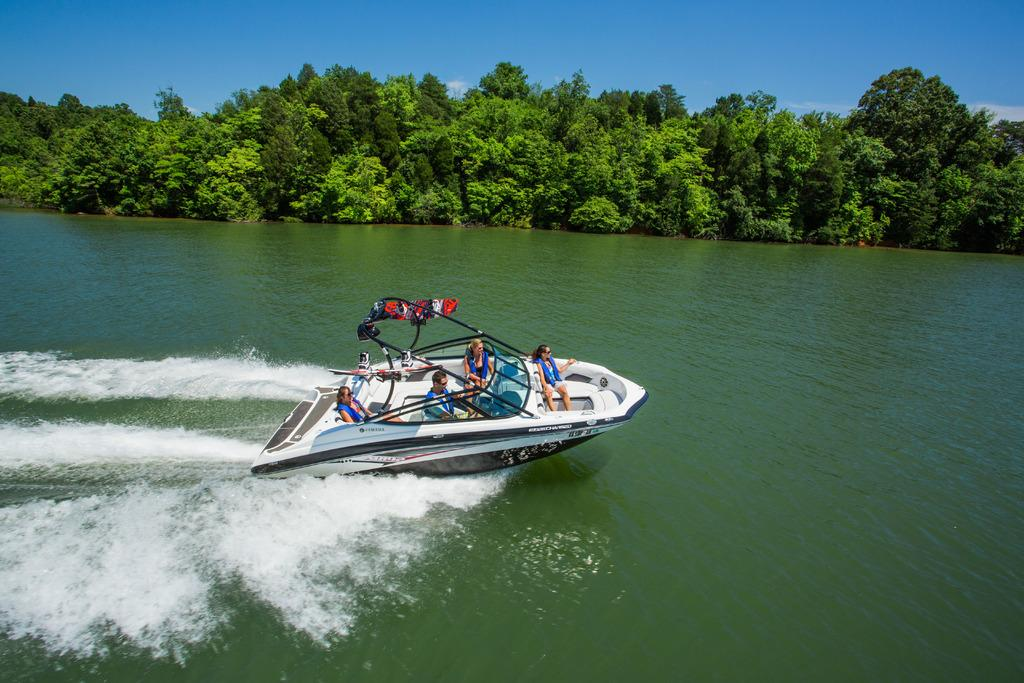What is the main subject in the center of the image? There is a steamer boat in the center of the image. Where is the boat located? The boat is on the water. Are there any passengers on the boat? Yes, there are people sitting in the boat. What can be seen in the background of the image? There are trees and the sky visible in the background of the image. What type of shirt is the cactus wearing in the image? There is no cactus or shirt present in the image; it features a steamer boat on the water with people sitting in it. 